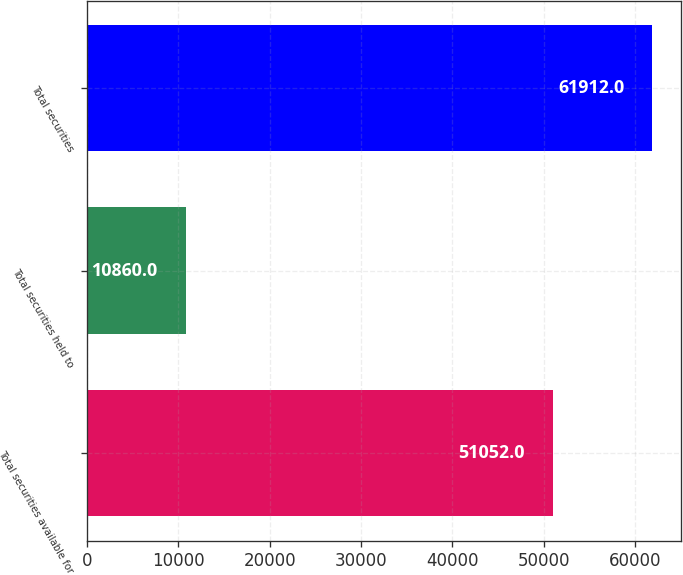<chart> <loc_0><loc_0><loc_500><loc_500><bar_chart><fcel>Total securities available for<fcel>Total securities held to<fcel>Total securities<nl><fcel>51052<fcel>10860<fcel>61912<nl></chart> 